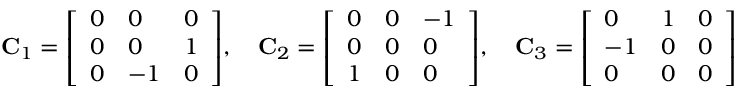Convert formula to latex. <formula><loc_0><loc_0><loc_500><loc_500>C _ { 1 } = { \left [ \begin{array} { l l l } { 0 } & { 0 } & { 0 } \\ { 0 } & { 0 } & { 1 } \\ { 0 } & { - 1 } & { 0 } \end{array} \right ] } , \quad C _ { 2 } = { \left [ \begin{array} { l l l } { 0 } & { 0 } & { - 1 } \\ { 0 } & { 0 } & { 0 } \\ { 1 } & { 0 } & { 0 } \end{array} \right ] } , \quad C _ { 3 } = { \left [ \begin{array} { l l l } { 0 } & { 1 } & { 0 } \\ { - 1 } & { 0 } & { 0 } \\ { 0 } & { 0 } & { 0 } \end{array} \right ] }</formula> 